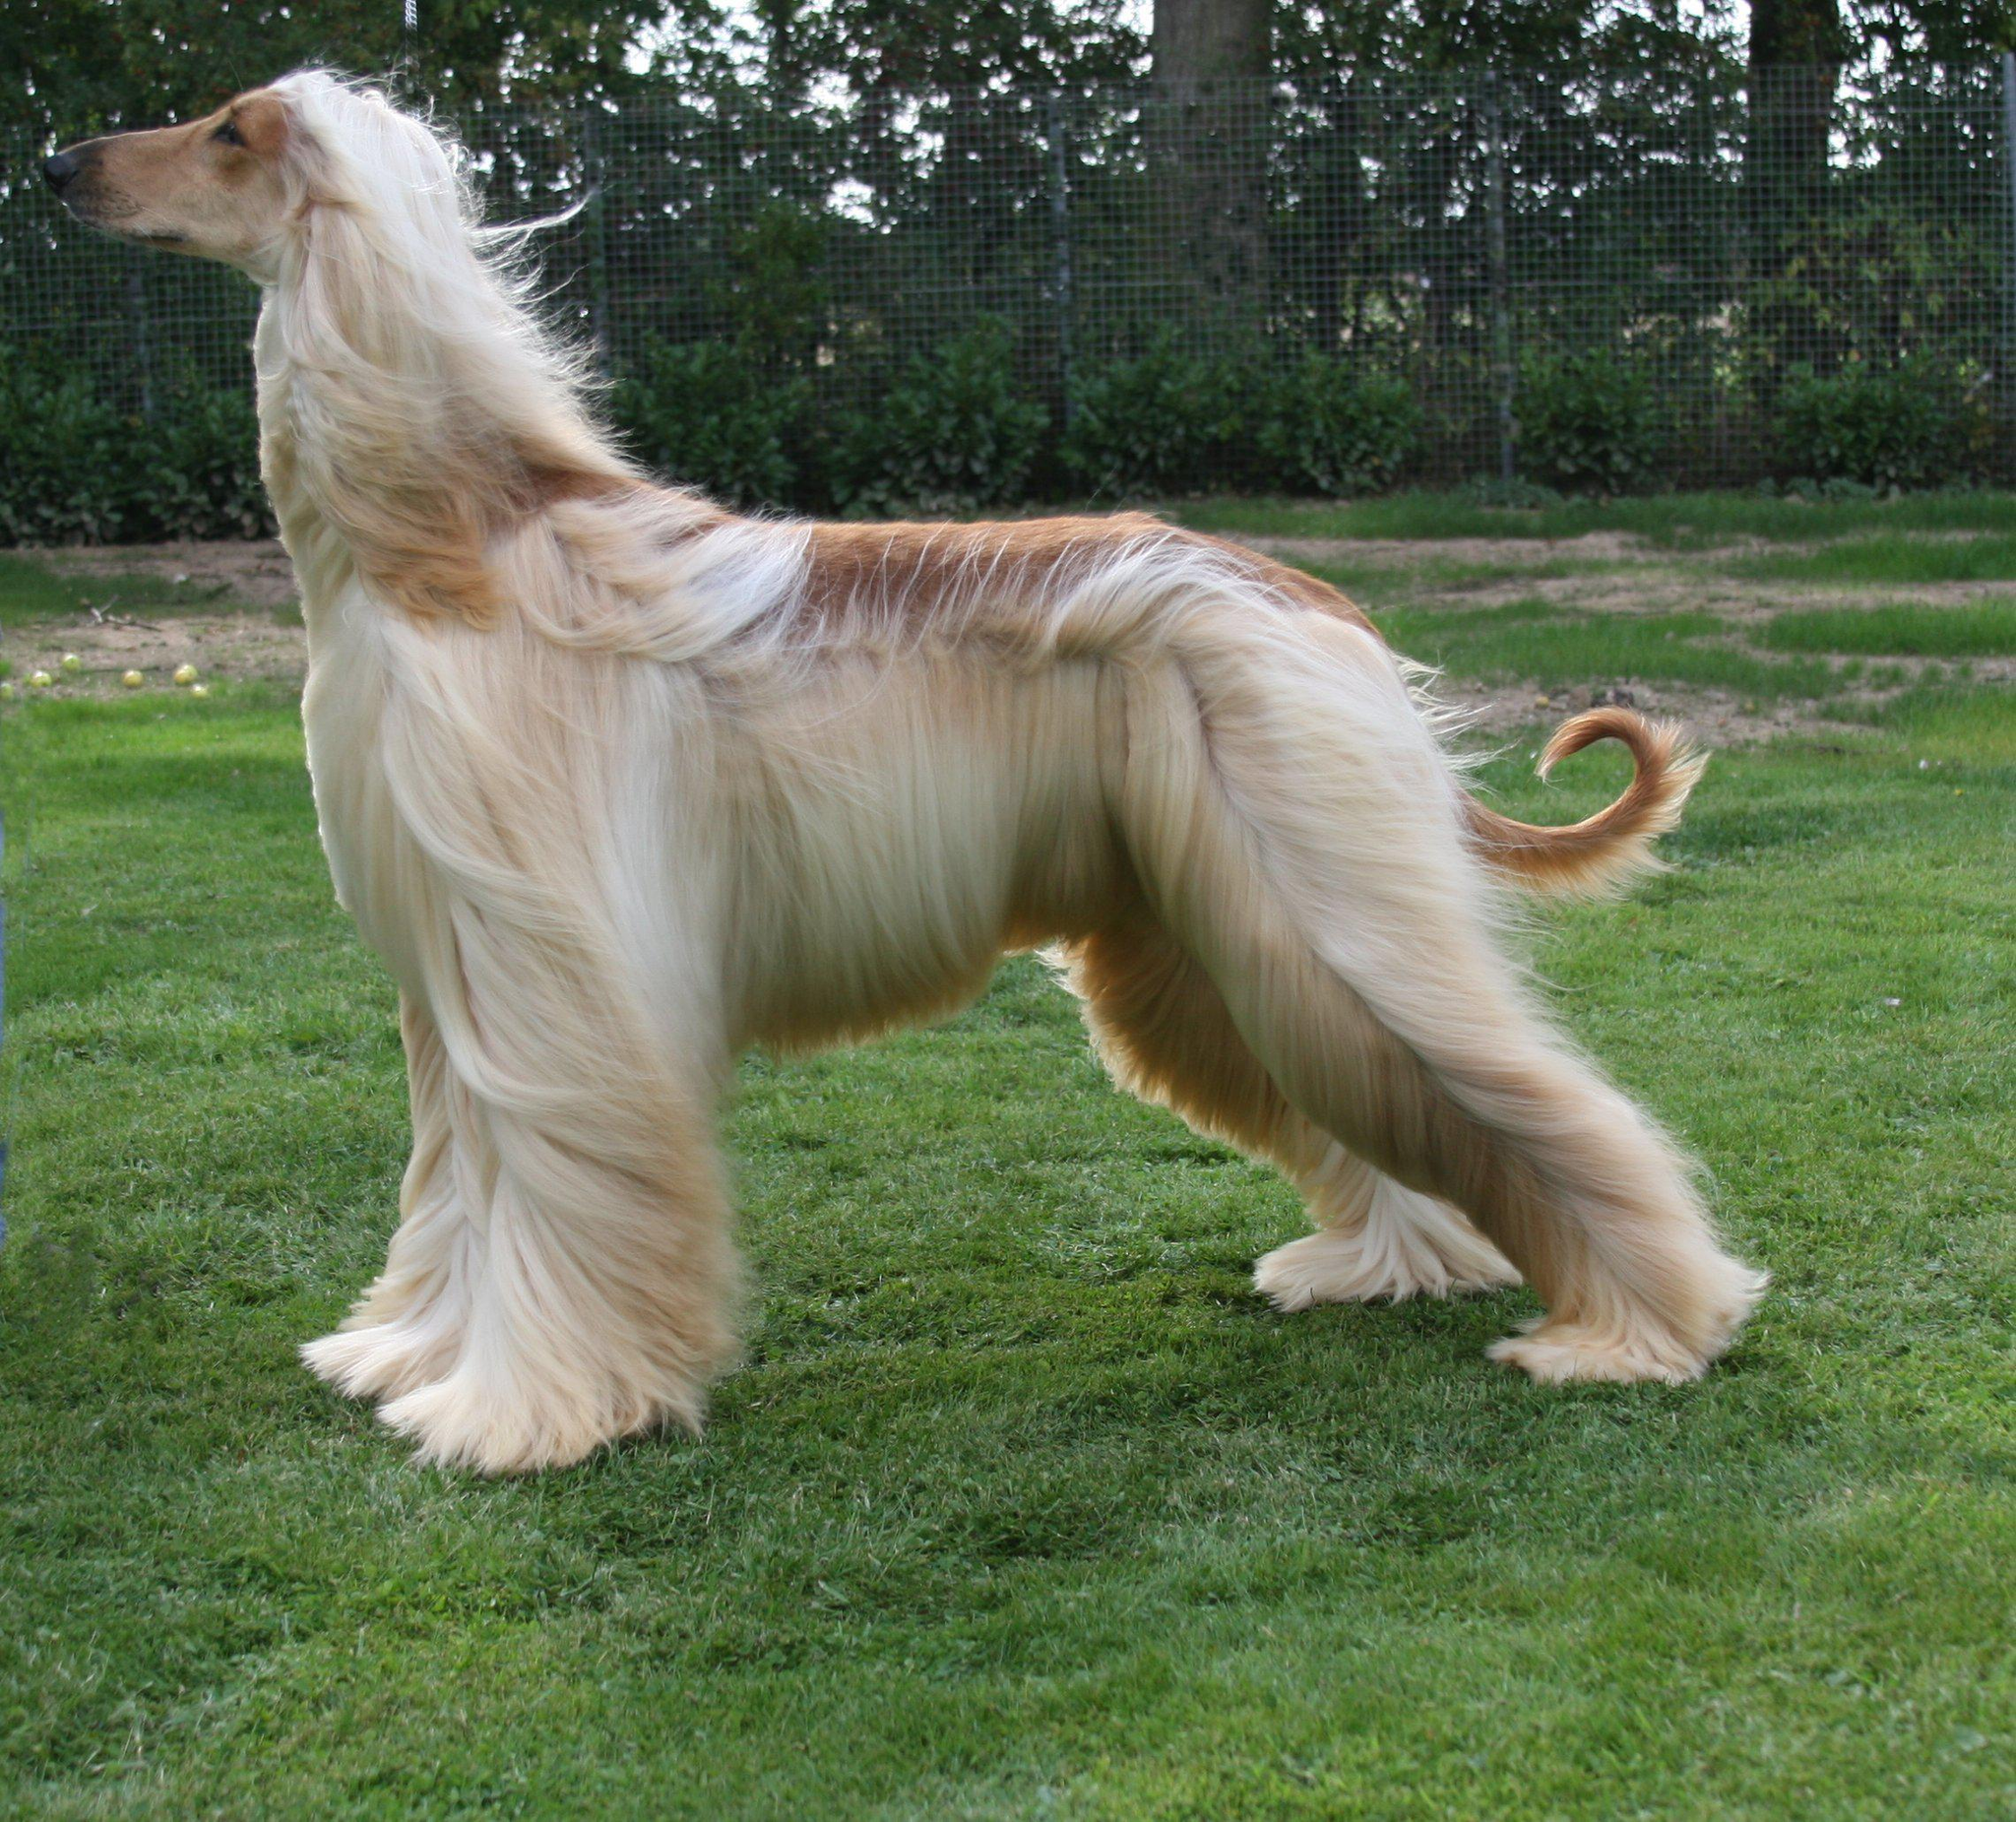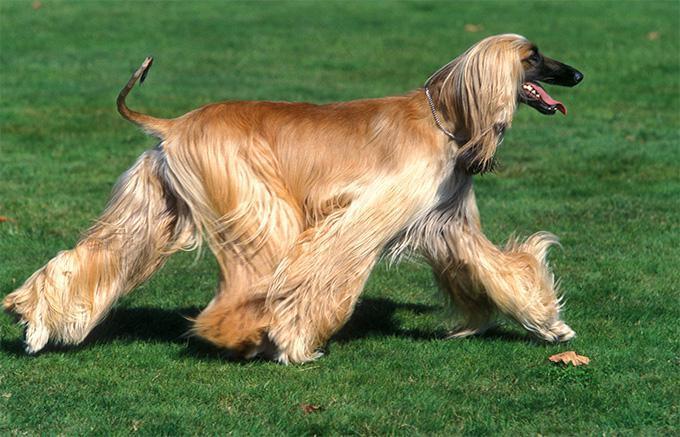The first image is the image on the left, the second image is the image on the right. For the images displayed, is the sentence "The dog in both images are standing in the grass." factually correct? Answer yes or no. Yes. The first image is the image on the left, the second image is the image on the right. Analyze the images presented: Is the assertion "The dogs in the two images have their bodies turned toward each other, and their heads both turned in the same direction." valid? Answer yes or no. No. 